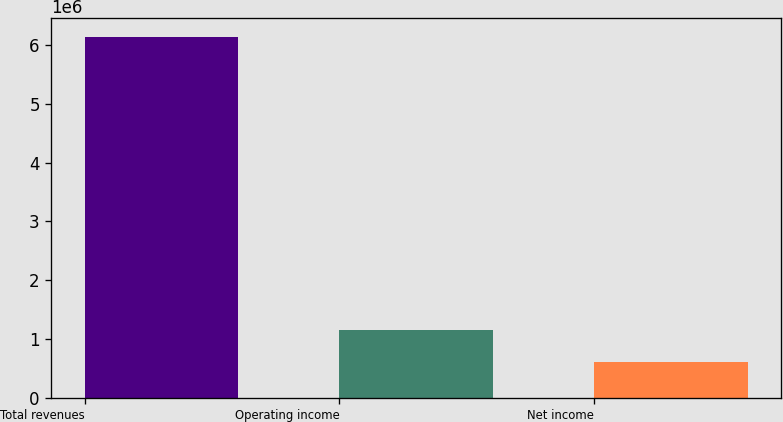Convert chart to OTSL. <chart><loc_0><loc_0><loc_500><loc_500><bar_chart><fcel>Total revenues<fcel>Operating income<fcel>Net income<nl><fcel>6.14914e+06<fcel>1.15798e+06<fcel>603405<nl></chart> 